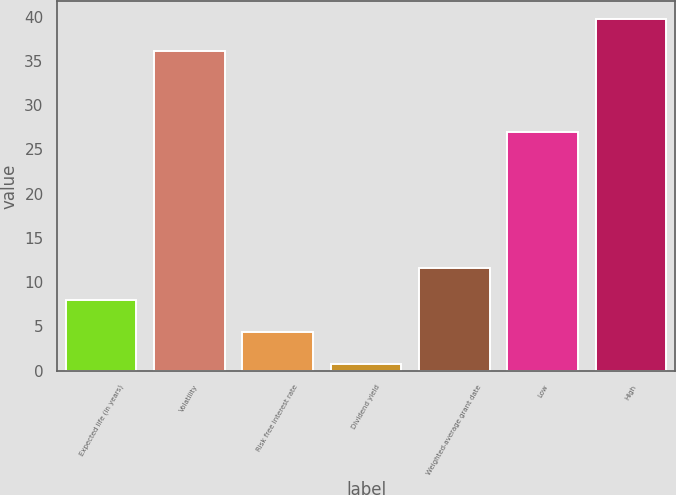Convert chart to OTSL. <chart><loc_0><loc_0><loc_500><loc_500><bar_chart><fcel>Expected life (in years)<fcel>Volatility<fcel>Risk free interest rate<fcel>Dividend yield<fcel>Weighted-average grant date<fcel>Low<fcel>High<nl><fcel>7.98<fcel>36.13<fcel>4.35<fcel>0.72<fcel>11.61<fcel>26.96<fcel>39.76<nl></chart> 